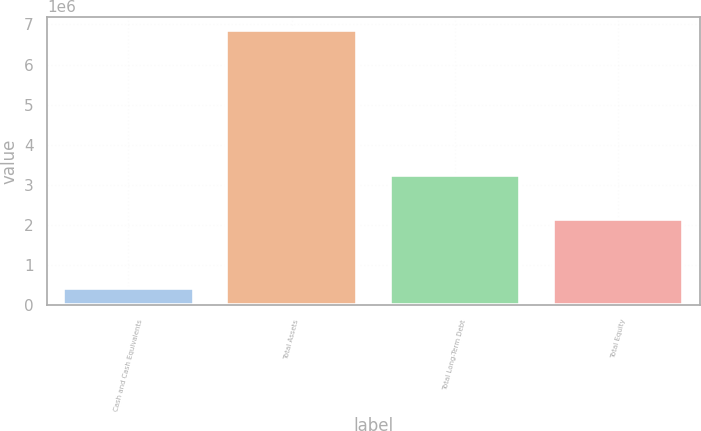Convert chart. <chart><loc_0><loc_0><loc_500><loc_500><bar_chart><fcel>Cash and Cash Equivalents<fcel>Total Assets<fcel>Total Long-Term Debt<fcel>Total Equity<nl><fcel>446656<fcel>6.85116e+06<fcel>3.24865e+06<fcel>2.15076e+06<nl></chart> 